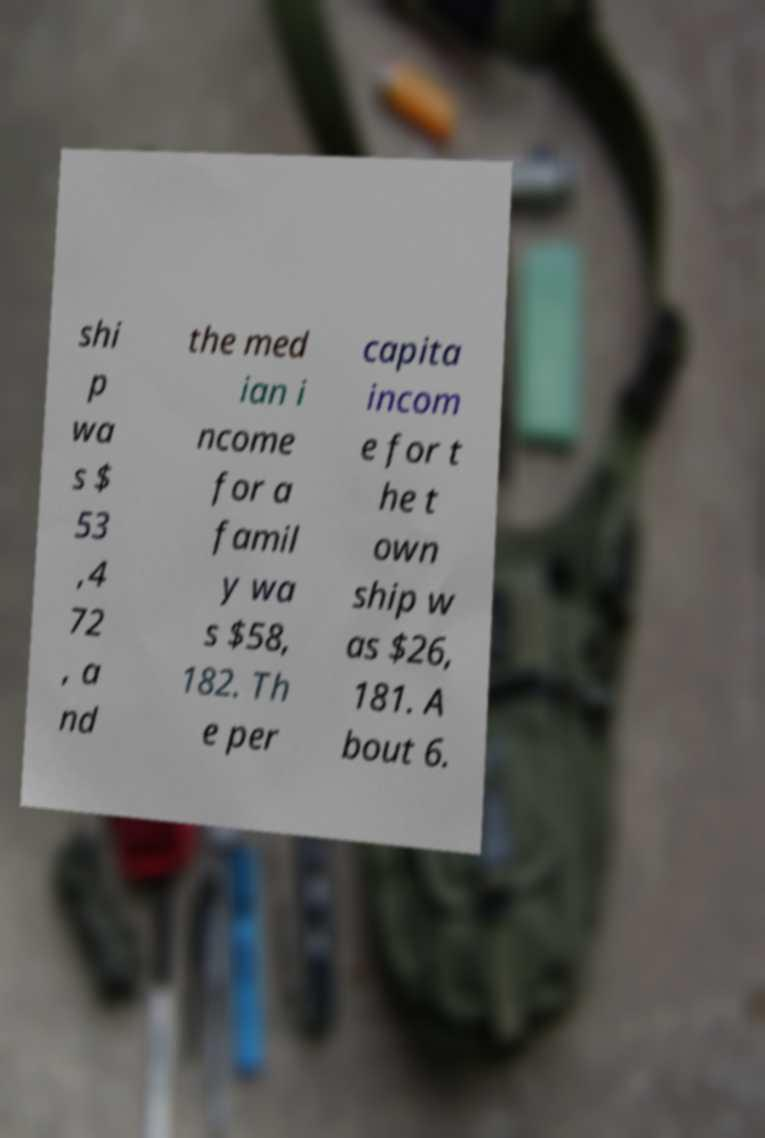Please identify and transcribe the text found in this image. shi p wa s $ 53 ,4 72 , a nd the med ian i ncome for a famil y wa s $58, 182. Th e per capita incom e for t he t own ship w as $26, 181. A bout 6. 